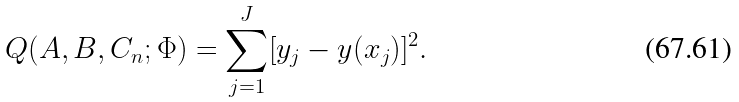<formula> <loc_0><loc_0><loc_500><loc_500>Q ( A , B , C _ { n } ; \Phi ) = \sum _ { j = 1 } ^ { J } [ y _ { j } - y ( x _ { j } ) ] ^ { 2 } .</formula> 